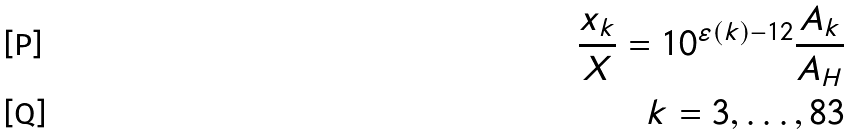Convert formula to latex. <formula><loc_0><loc_0><loc_500><loc_500>\frac { x _ { k } } { X } = 1 0 ^ { \varepsilon ( k ) - 1 2 } \frac { A _ { k } } { A _ { H } } \\ k = 3 , \dots , 8 3</formula> 